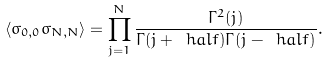Convert formula to latex. <formula><loc_0><loc_0><loc_500><loc_500>\langle \sigma _ { 0 , 0 } \sigma _ { N , N } \rangle = \prod ^ { N } _ { j = 1 } \frac { \Gamma ^ { 2 } ( j ) } { \Gamma ( j + \ h a l f ) \Gamma ( j - \ h a l f ) } .</formula> 